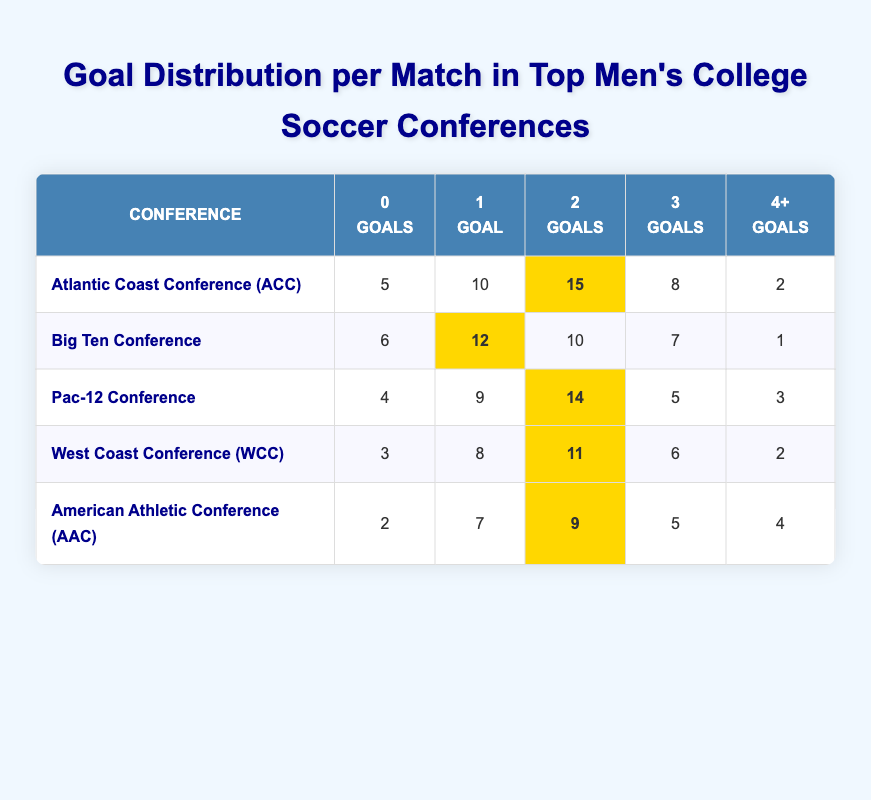What is the total number of matches played in the Atlantic Coast Conference? To find the total number of matches in the ACC, add all the goals scored across different categories: 5 (0 Goals) + 10 (1 Goal) + 15 (2 Goals) + 8 (3 Goals) + 2 (4+ Goals) = 40
Answer: 40 Which conference had the highest number of matches with 2 goals? Looking at the table, the highest number of matches with 2 goals can be found in the ACC with 15 matches, which is more than the other conferences: 15 (ACC), 10 (Big Ten), 14 (Pac-12), 11 (WCC), 9 (AAC).
Answer: Atlantic Coast Conference (ACC) How many matches had 4 or more goals in the Big Ten Conference? The table shows that there was 1 match with 4 or more goals in the Big Ten Conference.
Answer: 1 What is the combined number of matches with 0 and 1 goals in the Pac-12 Conference? To find the combined number of matches with 0 and 1 goals in the Pac-12, add the two values: 4 (0 Goals) + 9 (1 Goal) = 13.
Answer: 13 In the West Coast Conference, did more matches end with 3 goals or with 0 goals? In the WCC, 6 matches ended with 3 goals while 3 matches ended with 0 goals. Since 6 is greater than 3, the answer is yes.
Answer: Yes Which conference scored the least number of total goals in the 4+ category? Among all conferences, the American Athletic Conference had 4 matches with 4 or more goals, which is less than the other conferences: ACC with 2, Big Ten with 1, Pac-12 with 3, and WCC with 2.
Answer: Big Ten Conference How many matches had at least 3 goals in the Atlantic Coast Conference? To find this, add the matches with 3 goals and those with 4+ in the ACC: 8 (3 Goals) + 2 (4+ Goals) = 10.
Answer: 10 What percentage of matches in the American Athletic Conference had 1 goal? In the AAC, there were 7 matches with 1 goal out of a total of 27 matches. Therefore, the percentage is (7/27) * 100 = approximately 25.93%.
Answer: Approximately 25.93% 